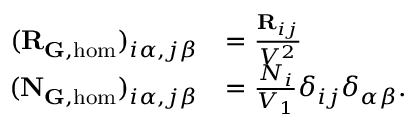<formula> <loc_0><loc_0><loc_500><loc_500>\begin{array} { r l } { ( R _ { { \mathbf G } , h o m } ) _ { i \alpha , j \beta } } & { = \frac { R _ { i j } } { V ^ { 2 } } } \\ { ( N _ { G , h o m } ) _ { i \alpha , j \beta } } & { = \frac { N _ { i } } { V _ { 1 } } \delta _ { i j } \delta _ { \alpha \beta } . } \end{array}</formula> 